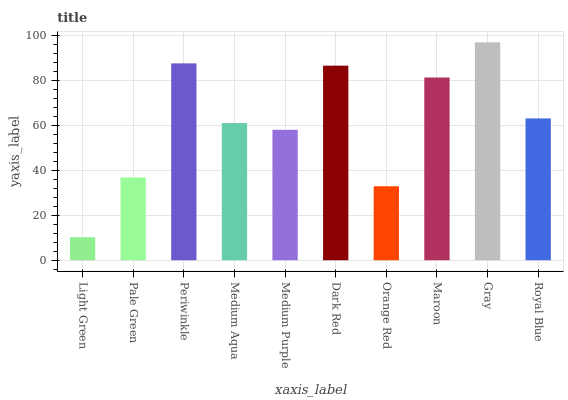Is Light Green the minimum?
Answer yes or no. Yes. Is Gray the maximum?
Answer yes or no. Yes. Is Pale Green the minimum?
Answer yes or no. No. Is Pale Green the maximum?
Answer yes or no. No. Is Pale Green greater than Light Green?
Answer yes or no. Yes. Is Light Green less than Pale Green?
Answer yes or no. Yes. Is Light Green greater than Pale Green?
Answer yes or no. No. Is Pale Green less than Light Green?
Answer yes or no. No. Is Royal Blue the high median?
Answer yes or no. Yes. Is Medium Aqua the low median?
Answer yes or no. Yes. Is Medium Purple the high median?
Answer yes or no. No. Is Pale Green the low median?
Answer yes or no. No. 